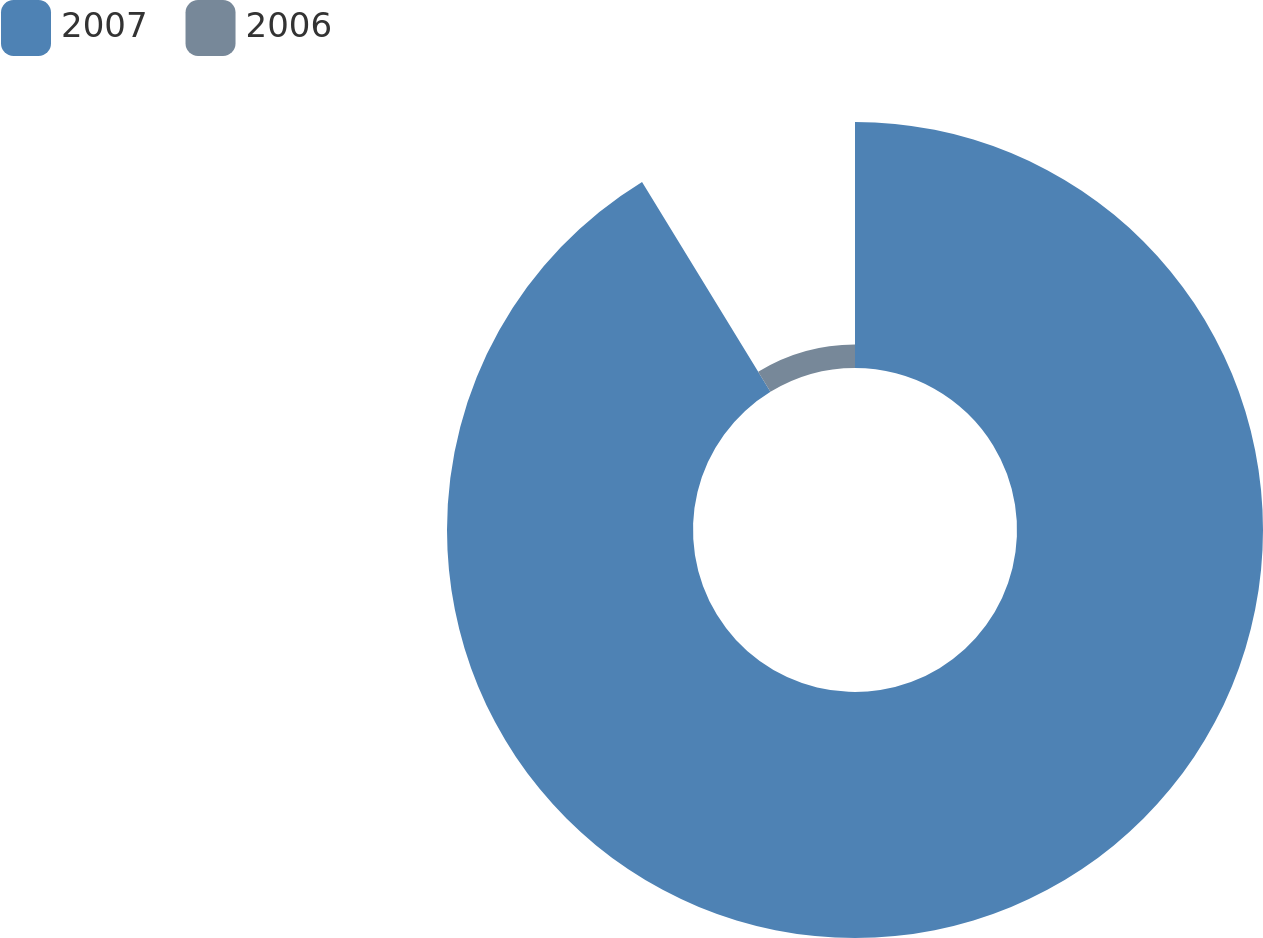Convert chart to OTSL. <chart><loc_0><loc_0><loc_500><loc_500><pie_chart><fcel>2007<fcel>2006<nl><fcel>91.26%<fcel>8.74%<nl></chart> 